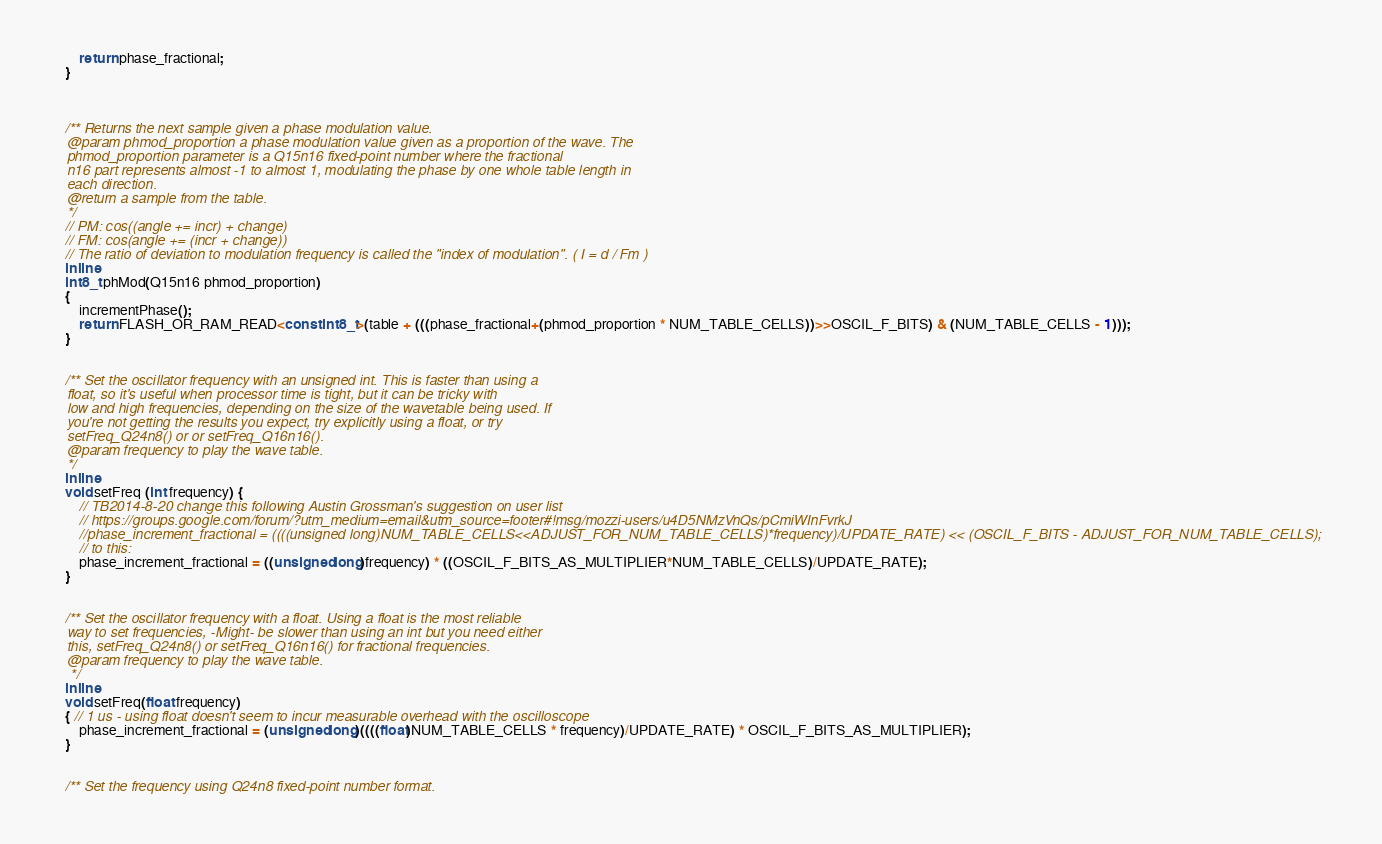<code> <loc_0><loc_0><loc_500><loc_500><_C_>		return phase_fractional;
	}



	/** Returns the next sample given a phase modulation value.
	@param phmod_proportion a phase modulation value given as a proportion of the wave. The
	phmod_proportion parameter is a Q15n16 fixed-point number where the fractional
	n16 part represents almost -1 to almost 1, modulating the phase by one whole table length in
	each direction.
	@return a sample from the table.
	*/
	// PM: cos((angle += incr) + change)
	// FM: cos(angle += (incr + change))
	// The ratio of deviation to modulation frequency is called the "index of modulation". ( I = d / Fm )
	inline
	int8_t phMod(Q15n16 phmod_proportion)
	{
		incrementPhase();
		return FLASH_OR_RAM_READ<const int8_t>(table + (((phase_fractional+(phmod_proportion * NUM_TABLE_CELLS))>>OSCIL_F_BITS) & (NUM_TABLE_CELLS - 1)));
	}


	/** Set the oscillator frequency with an unsigned int. This is faster than using a
	float, so it's useful when processor time is tight, but it can be tricky with
	low and high frequencies, depending on the size of the wavetable being used. If
	you're not getting the results you expect, try explicitly using a float, or try
	setFreq_Q24n8() or or setFreq_Q16n16().
	@param frequency to play the wave table.
	*/
	inline
	void setFreq (int frequency) {
		// TB2014-8-20 change this following Austin Grossman's suggestion on user list
		// https://groups.google.com/forum/?utm_medium=email&utm_source=footer#!msg/mozzi-users/u4D5NMzVnQs/pCmiWInFvrkJ
		//phase_increment_fractional = ((((unsigned long)NUM_TABLE_CELLS<<ADJUST_FOR_NUM_TABLE_CELLS)*frequency)/UPDATE_RATE) << (OSCIL_F_BITS - ADJUST_FOR_NUM_TABLE_CELLS);
		// to this:
		phase_increment_fractional = ((unsigned long)frequency) * ((OSCIL_F_BITS_AS_MULTIPLIER*NUM_TABLE_CELLS)/UPDATE_RATE);
	}


	/** Set the oscillator frequency with a float. Using a float is the most reliable
	way to set frequencies, -Might- be slower than using an int but you need either
	this, setFreq_Q24n8() or setFreq_Q16n16() for fractional frequencies.
	@param frequency to play the wave table.
	 */
	inline
	void setFreq(float frequency)
	{ // 1 us - using float doesn't seem to incur measurable overhead with the oscilloscope
		phase_increment_fractional = (unsigned long)((((float)NUM_TABLE_CELLS * frequency)/UPDATE_RATE) * OSCIL_F_BITS_AS_MULTIPLIER);
	}


	/** Set the frequency using Q24n8 fixed-point number format.</code> 